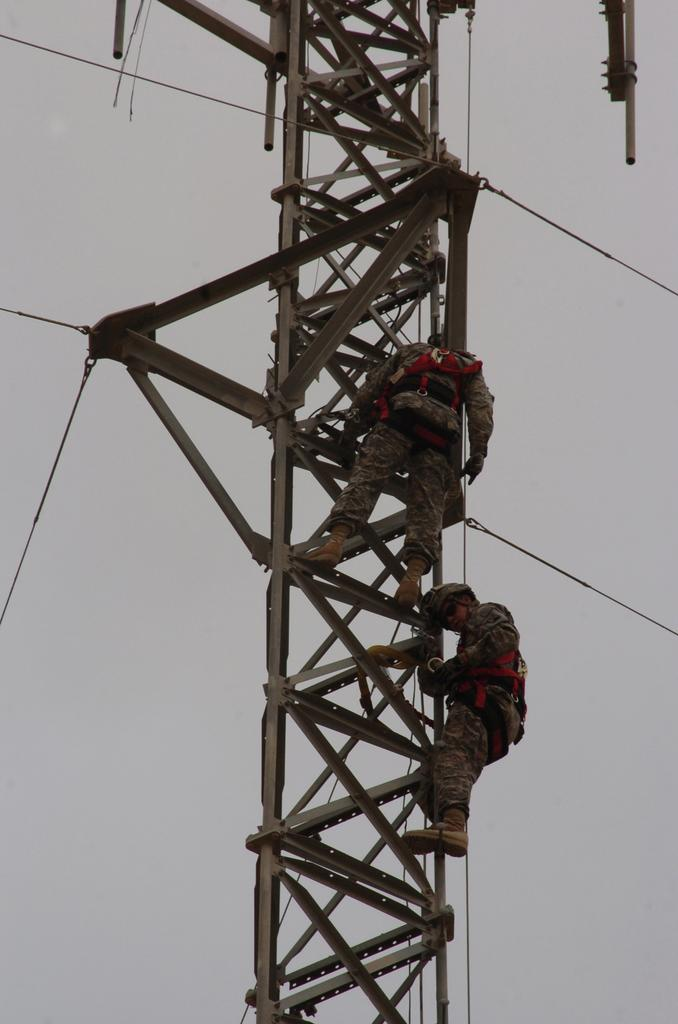What is the main structure in the middle of the image? There is a tower in the middle of the image. Can you describe the people in the image? There are people in the image, but their specific actions or appearances are not mentioned in the facts. What else can be seen in the image besides the tower and people? Cables are visible in the image. Are there any ghosts visible in the image? There is no mention of ghosts in the provided facts, so we cannot determine if any are present in the image. Is there a playground in the image? There is no mention of a playground in the provided facts, so we cannot determine if one is present in the image. 